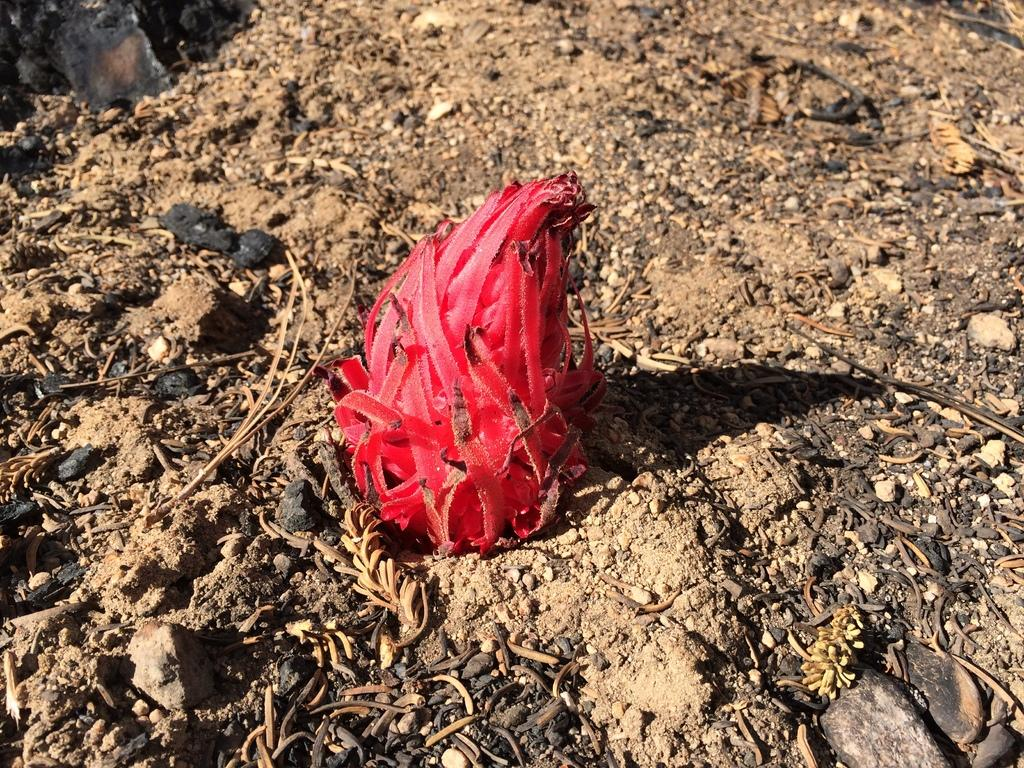What can be seen at the base of the image? The ground is visible in the image. How would you describe the condition of the ground? The ground appears to be messy. What objects can be found on the ground? There are twigs on the ground. What type of fruit is present in the image? There is a dragon fruit in the image. How does the beginner learn to play the pan in the image? There is no pan or beginner present in the image, so it is not possible to answer that question. 